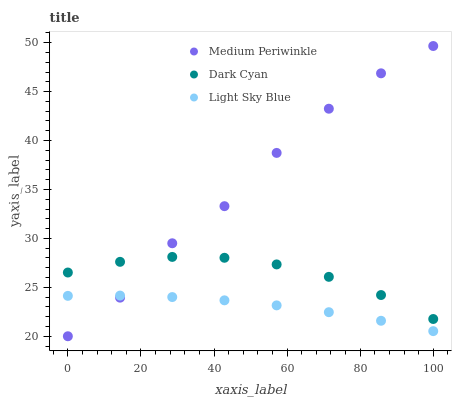Does Light Sky Blue have the minimum area under the curve?
Answer yes or no. Yes. Does Medium Periwinkle have the maximum area under the curve?
Answer yes or no. Yes. Does Medium Periwinkle have the minimum area under the curve?
Answer yes or no. No. Does Light Sky Blue have the maximum area under the curve?
Answer yes or no. No. Is Light Sky Blue the smoothest?
Answer yes or no. Yes. Is Medium Periwinkle the roughest?
Answer yes or no. Yes. Is Medium Periwinkle the smoothest?
Answer yes or no. No. Is Light Sky Blue the roughest?
Answer yes or no. No. Does Medium Periwinkle have the lowest value?
Answer yes or no. Yes. Does Light Sky Blue have the lowest value?
Answer yes or no. No. Does Medium Periwinkle have the highest value?
Answer yes or no. Yes. Does Light Sky Blue have the highest value?
Answer yes or no. No. Is Light Sky Blue less than Dark Cyan?
Answer yes or no. Yes. Is Dark Cyan greater than Light Sky Blue?
Answer yes or no. Yes. Does Light Sky Blue intersect Medium Periwinkle?
Answer yes or no. Yes. Is Light Sky Blue less than Medium Periwinkle?
Answer yes or no. No. Is Light Sky Blue greater than Medium Periwinkle?
Answer yes or no. No. Does Light Sky Blue intersect Dark Cyan?
Answer yes or no. No. 